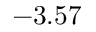Convert formula to latex. <formula><loc_0><loc_0><loc_500><loc_500>- 3 . 5 7</formula> 